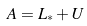<formula> <loc_0><loc_0><loc_500><loc_500>A = L _ { * } + U</formula> 